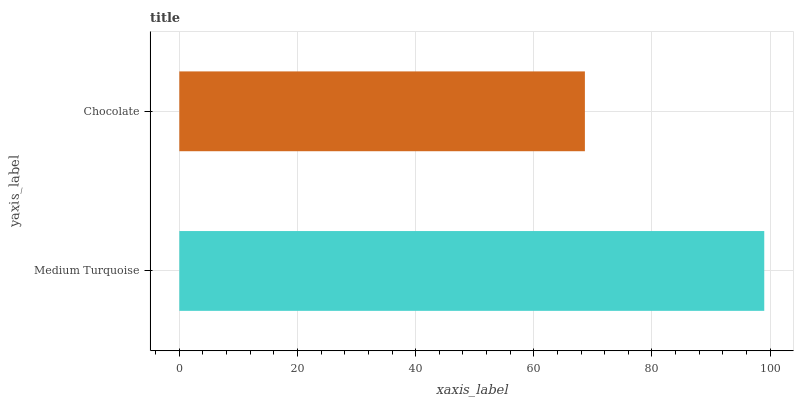Is Chocolate the minimum?
Answer yes or no. Yes. Is Medium Turquoise the maximum?
Answer yes or no. Yes. Is Chocolate the maximum?
Answer yes or no. No. Is Medium Turquoise greater than Chocolate?
Answer yes or no. Yes. Is Chocolate less than Medium Turquoise?
Answer yes or no. Yes. Is Chocolate greater than Medium Turquoise?
Answer yes or no. No. Is Medium Turquoise less than Chocolate?
Answer yes or no. No. Is Medium Turquoise the high median?
Answer yes or no. Yes. Is Chocolate the low median?
Answer yes or no. Yes. Is Chocolate the high median?
Answer yes or no. No. Is Medium Turquoise the low median?
Answer yes or no. No. 